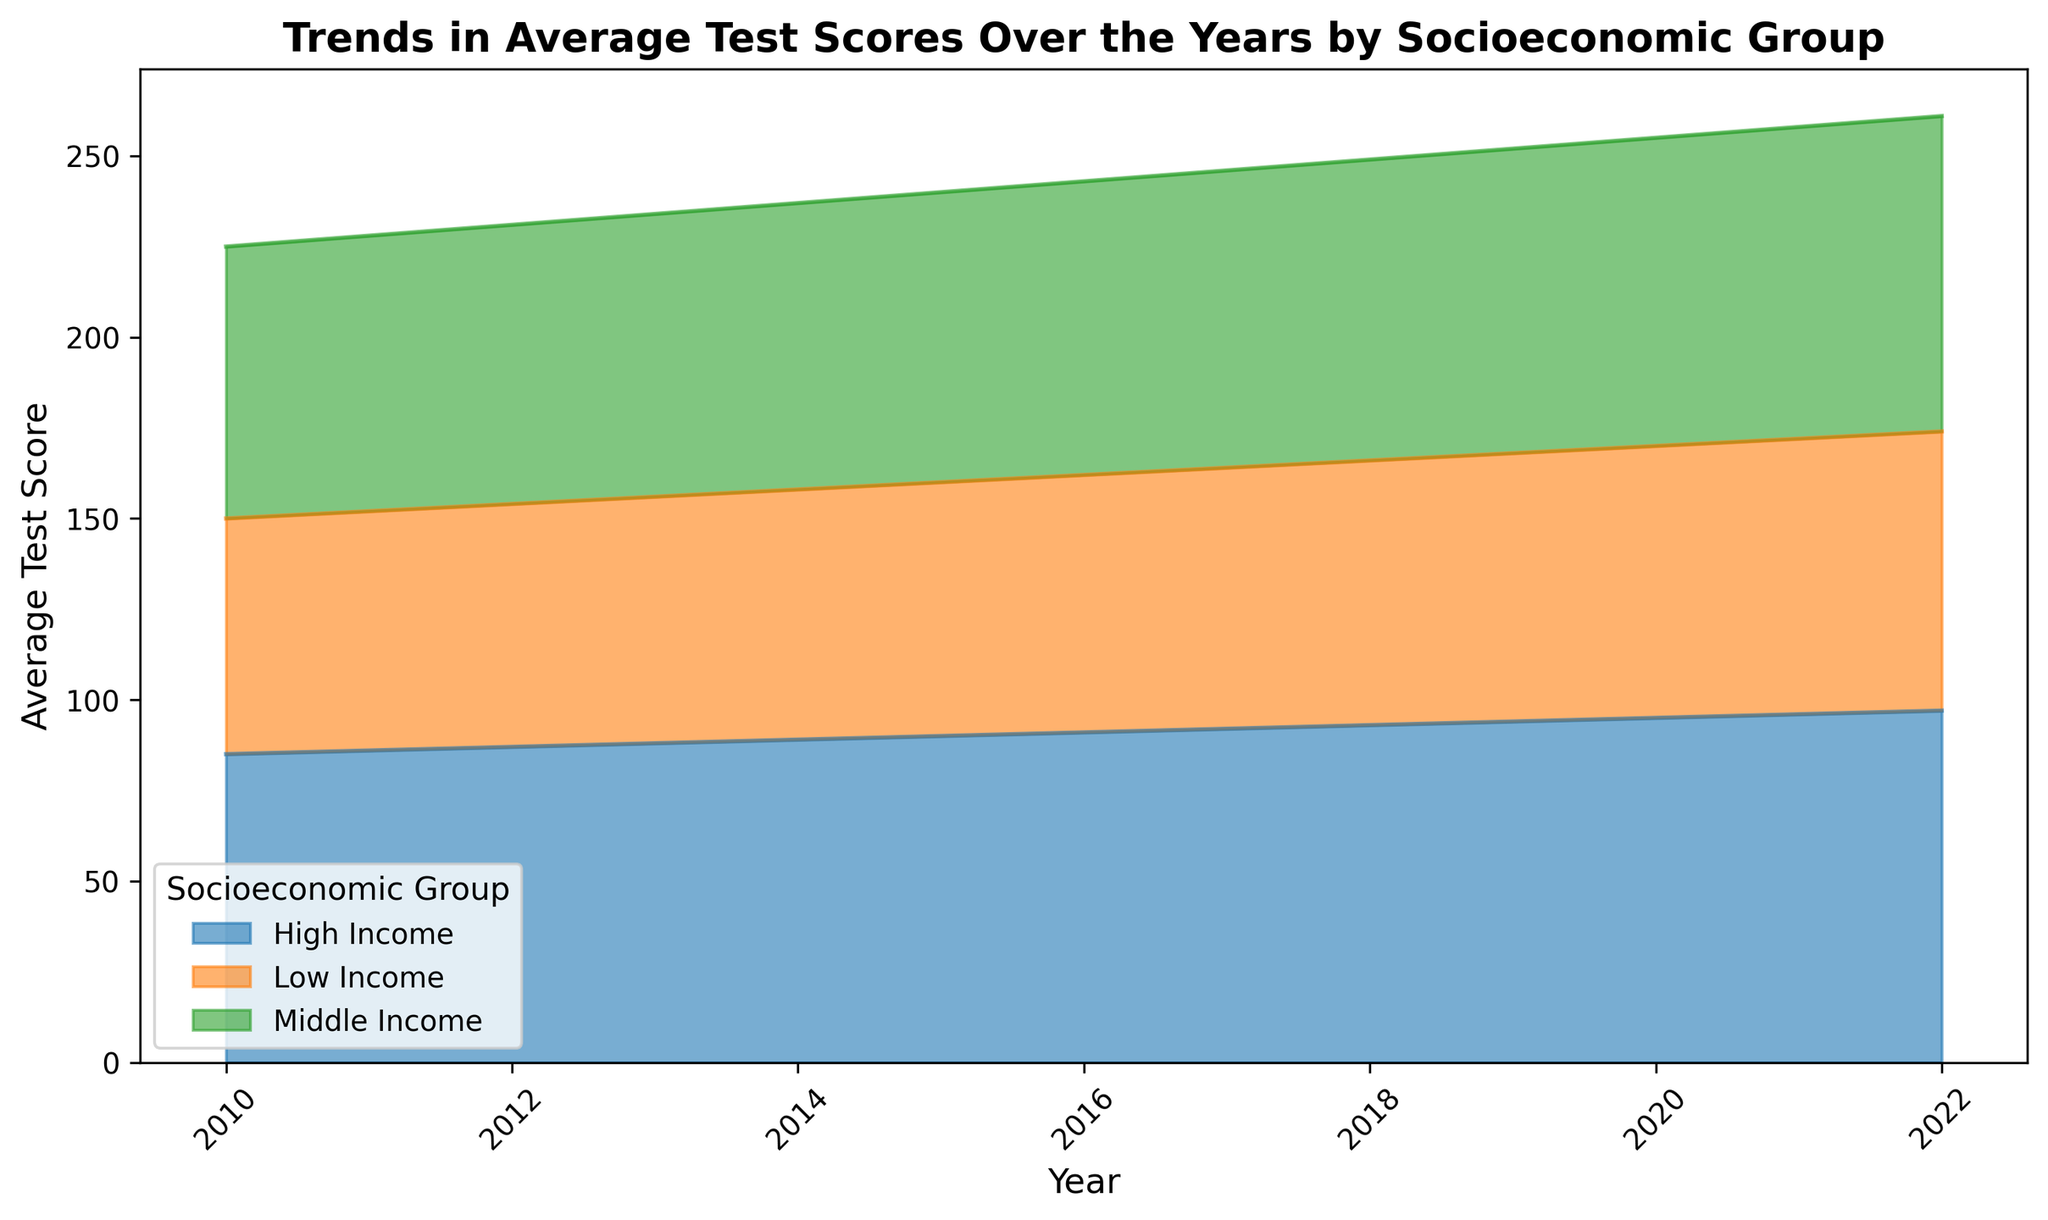What year does the High Income group reach an average test score of 96? In the chart, look for the point where the line representing the High Income group intersects the 96 mark on the y-axis. This occurs in 2021.
Answer: 2021 Which socioeconomic group shows the highest increase in average test scores from 2010 to 2022? Compare the changes in test scores for each group from 2010 to 2022. Low Income rises from 65 to 77 (increase of 12), Middle Income goes from 75 to 87 (increase of 12), and High Income goes from 85 to 97 (increase of 12). All groups have equal increases.
Answer: All groups In which year does the Middle Income group surpass an average test score of 84? Locate the point on the area chart where the Middle Income group's score exceeds 84 on the y-axis. This occurs in 2019.
Answer: 2019 What is the difference in average test scores between the High Income and Low Income groups in 2010? Find the test scores for High Income (85) and Low Income (65) in 2010, then subtract the Low Income score from the High Income score. 85 - 65 = 20.
Answer: 20 How does the trend in average test scores from 2010 to 2022 differ between the Low Income and Middle Income groups? Examine the slopes of the lines representing Low and Middle Income groups. Both exhibit an upward trend, but the actual values differ. The Low Income group starts lower and increases steadily, while the Middle Income group starts higher but also increases at a similar rate.
Answer: Similar upward trend Which socioeconomic group had the highest average test score in 2016? Look for the peak of the area representing the highest test score in 2016. The High Income group is the top layer, indicating the highest score.
Answer: High Income What year marks the first time the Low Income group reaches an average test score of 70? Find the point at which the Low Income group's line hits 70 on the y-axis. This happens in 2015.
Answer: 2015 Between 2015 and 2020, how much did the average test score increase for the Low Income group? Identify the scores for 2015 (70) and 2020 (75) and subtract the 2015 score from the 2020 score. 75 - 70 = 5.
Answer: 5 Compare the difference in average test scores between the High Income and Middle Income groups in 2022. Find the scores for High Income (97) and Middle Income (87) in 2022. Then subtract the Middle Income score from the High Income score. 97 - 87 = 10.
Answer: 10 Visually, which socioeconomic group's area appears to have the most consistent growth trend from 2010 to 2022? Examine the smoothness and consistency of the area for each group. The Low Income group's area shows the most uniform and steady increase over the years.
Answer: Low Income 